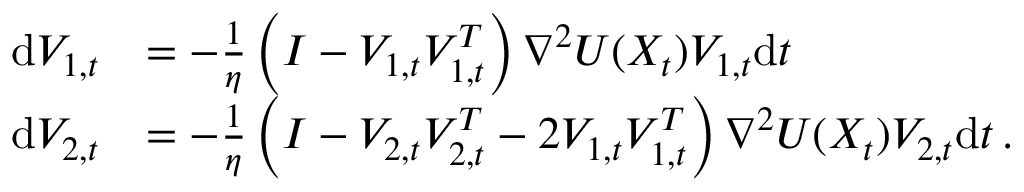Convert formula to latex. <formula><loc_0><loc_0><loc_500><loc_500>\begin{array} { r l } { d V _ { 1 , t } } & { = - \frac { 1 } \eta \left ( I - V _ { 1 , t } V _ { 1 , t } ^ { T } \right ) \nabla ^ { 2 } U ( X _ { t } ) V _ { 1 , t } d t } \\ { d V _ { 2 , t } } & { = - \frac { 1 } \eta \left ( I - V _ { 2 , t } V _ { 2 , t } ^ { T } - 2 V _ { 1 , t } V _ { 1 , t } ^ { T } \right ) \nabla ^ { 2 } U ( X _ { t } ) V _ { 2 , t } d t \, . } \end{array}</formula> 